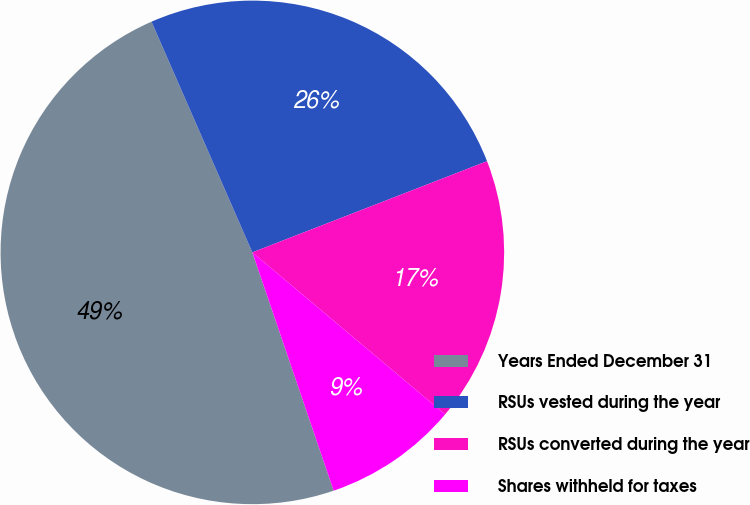Convert chart to OTSL. <chart><loc_0><loc_0><loc_500><loc_500><pie_chart><fcel>Years Ended December 31<fcel>RSUs vested during the year<fcel>RSUs converted during the year<fcel>Shares withheld for taxes<nl><fcel>48.67%<fcel>25.66%<fcel>17.02%<fcel>8.64%<nl></chart> 